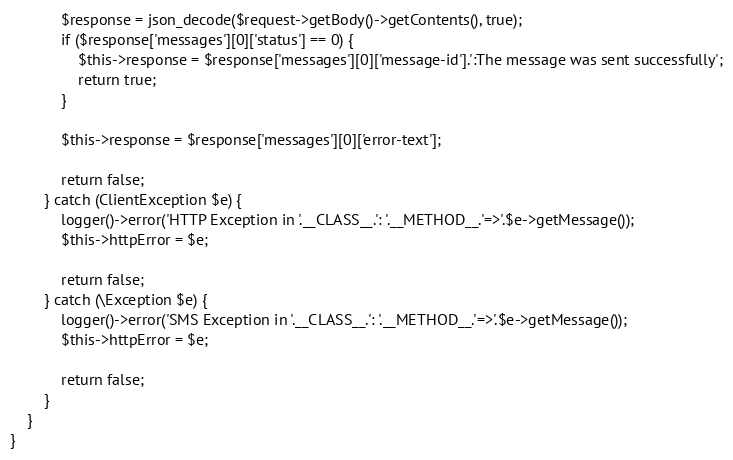<code> <loc_0><loc_0><loc_500><loc_500><_PHP_>            $response = json_decode($request->getBody()->getContents(), true);
            if ($response['messages'][0]['status'] == 0) {
                $this->response = $response['messages'][0]['message-id'].':The message was sent successfully';
                return true;
            }

            $this->response = $response['messages'][0]['error-text'];

            return false;
        } catch (ClientException $e) {
            logger()->error('HTTP Exception in '.__CLASS__.': '.__METHOD__.'=>'.$e->getMessage());
            $this->httpError = $e;

            return false;
        } catch (\Exception $e) {
            logger()->error('SMS Exception in '.__CLASS__.': '.__METHOD__.'=>'.$e->getMessage());
            $this->httpError = $e;

            return false;
        }
    }
}
</code> 